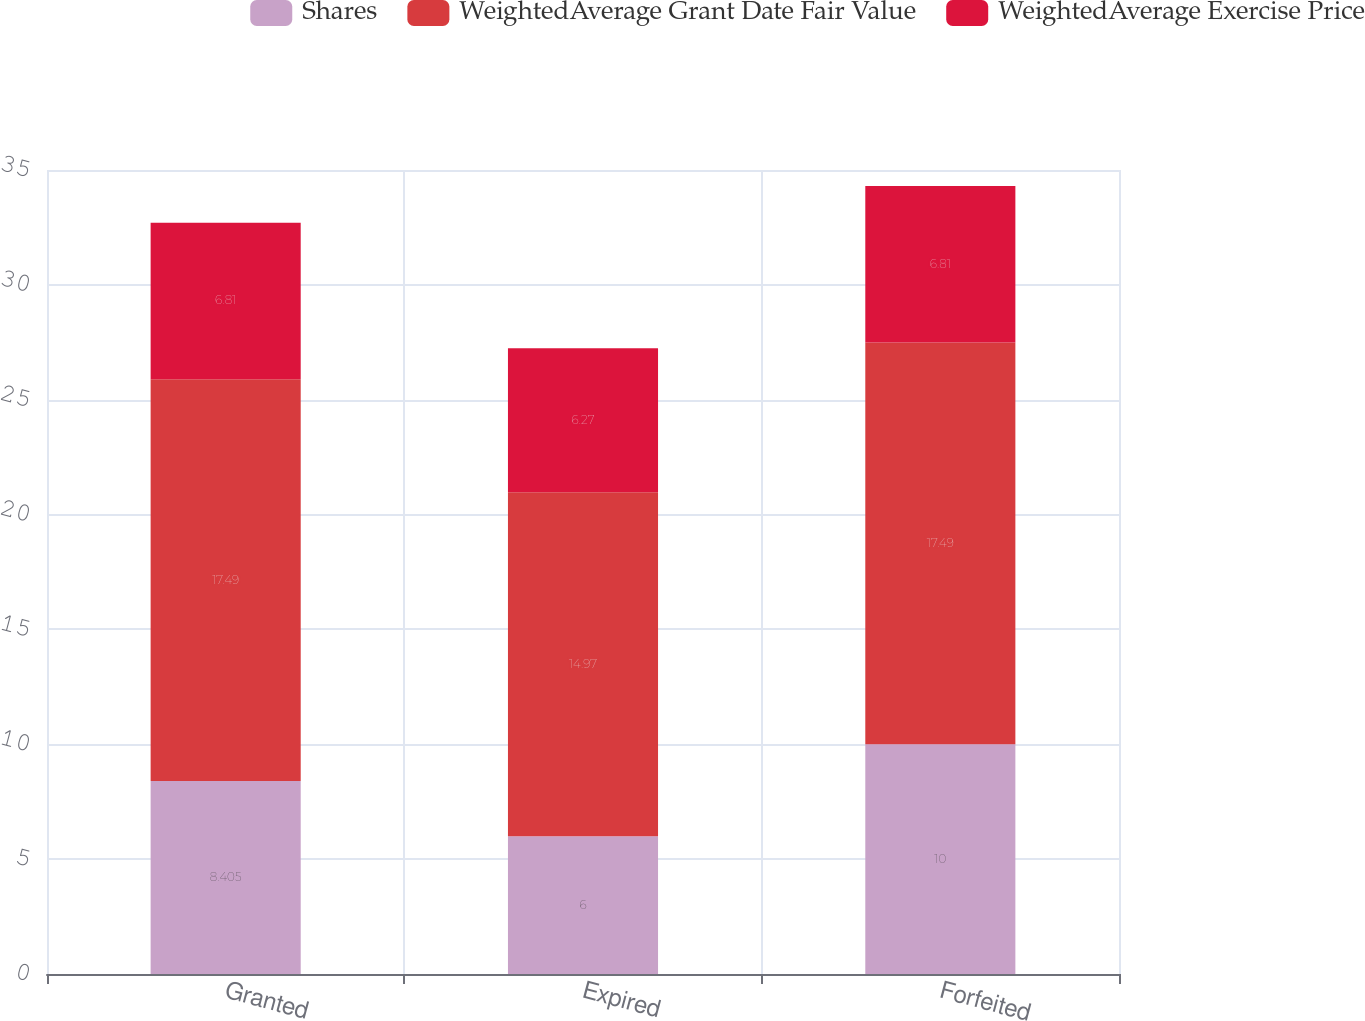Convert chart. <chart><loc_0><loc_0><loc_500><loc_500><stacked_bar_chart><ecel><fcel>Granted<fcel>Expired<fcel>Forfeited<nl><fcel>Shares<fcel>8.405<fcel>6<fcel>10<nl><fcel>WeightedAverage Grant Date Fair Value<fcel>17.49<fcel>14.97<fcel>17.49<nl><fcel>WeightedAverage Exercise Price<fcel>6.81<fcel>6.27<fcel>6.81<nl></chart> 